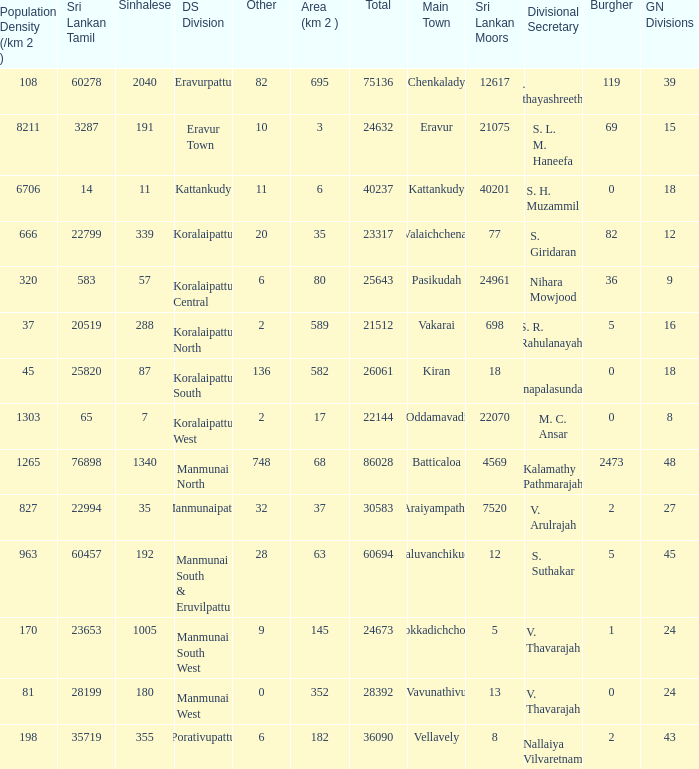What is the name of the DS division where the divisional secretary is S. H. Muzammil? Kattankudy. 